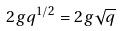<formula> <loc_0><loc_0><loc_500><loc_500>2 g q ^ { 1 / 2 } = 2 g \sqrt { q }</formula> 